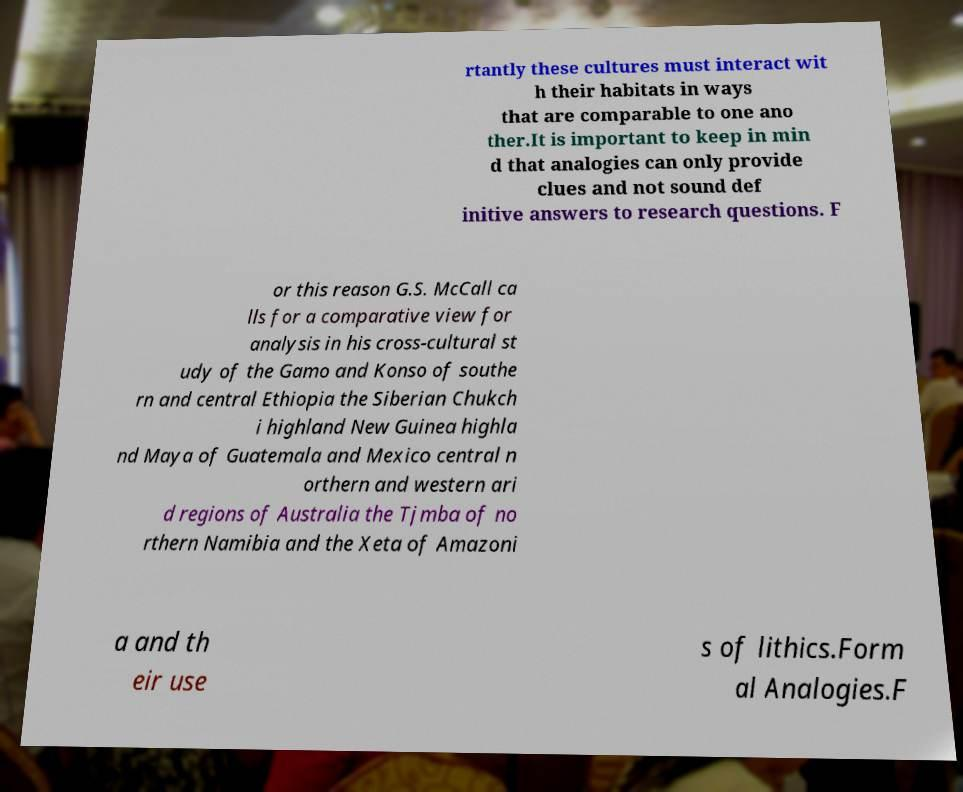There's text embedded in this image that I need extracted. Can you transcribe it verbatim? rtantly these cultures must interact wit h their habitats in ways that are comparable to one ano ther.It is important to keep in min d that analogies can only provide clues and not sound def initive answers to research questions. F or this reason G.S. McCall ca lls for a comparative view for analysis in his cross-cultural st udy of the Gamo and Konso of southe rn and central Ethiopia the Siberian Chukch i highland New Guinea highla nd Maya of Guatemala and Mexico central n orthern and western ari d regions of Australia the Tjmba of no rthern Namibia and the Xeta of Amazoni a and th eir use s of lithics.Form al Analogies.F 